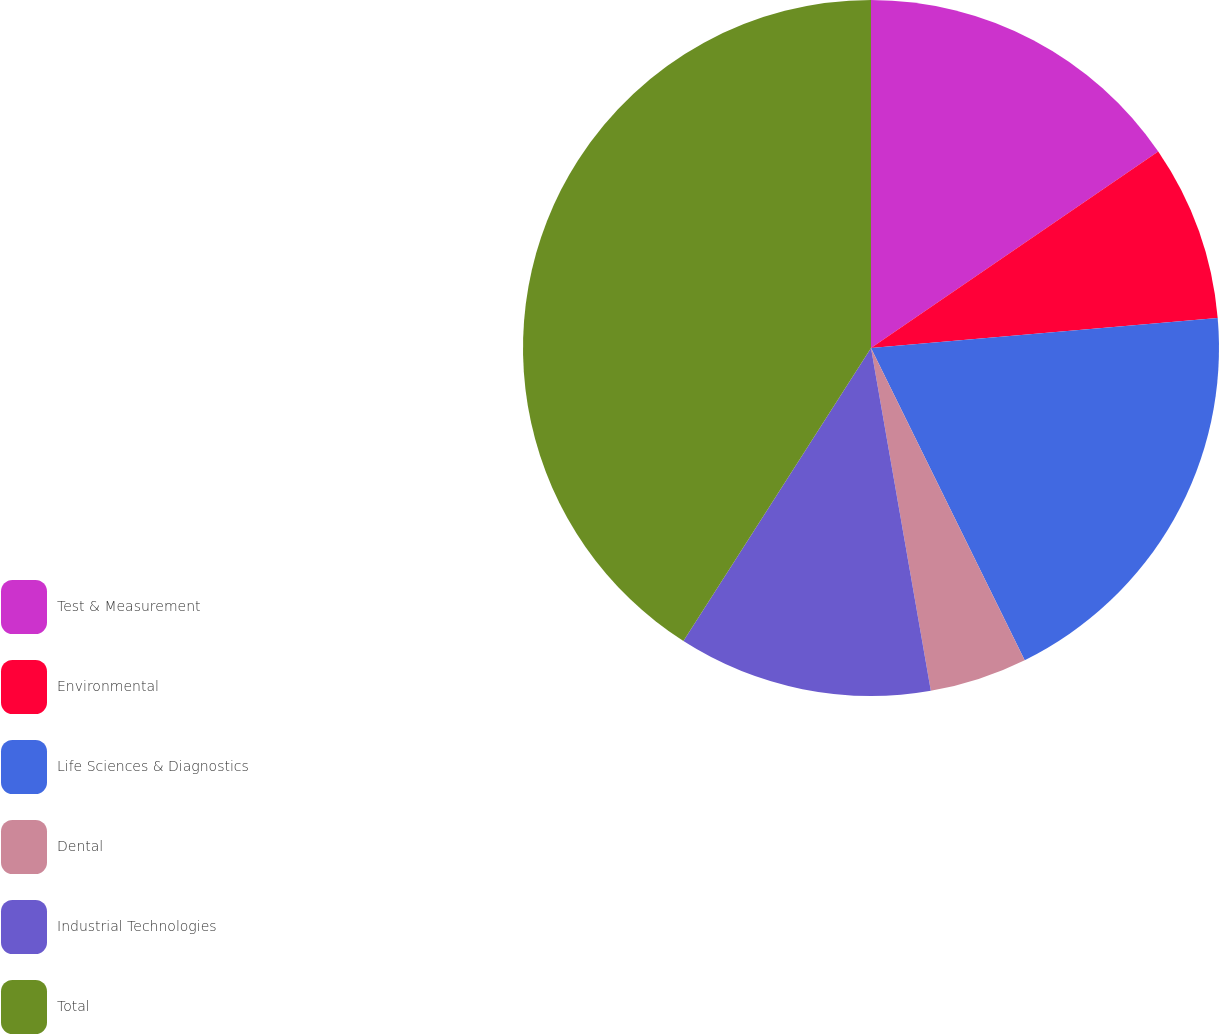<chart> <loc_0><loc_0><loc_500><loc_500><pie_chart><fcel>Test & Measurement<fcel>Environmental<fcel>Life Sciences & Diagnostics<fcel>Dental<fcel>Industrial Technologies<fcel>Total<nl><fcel>15.45%<fcel>8.17%<fcel>19.09%<fcel>4.53%<fcel>11.81%<fcel>40.93%<nl></chart> 